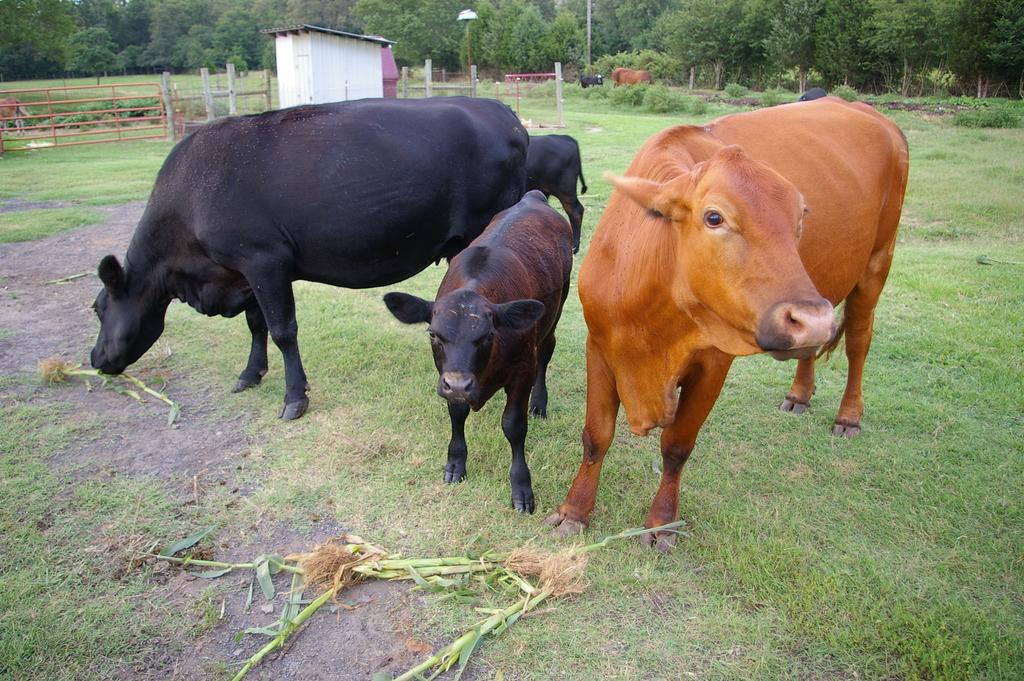What is on the ground in the image? There is a group of herd on the ground. What type of vegetation is visible in the image? There is grass visible in the image. What can be seen in the background of the image? There is a house with a roof, a fence, poles, and a group of trees in the background. What type of egg is being used to whistle in the image? There is no egg or whistling activity present in the image. 